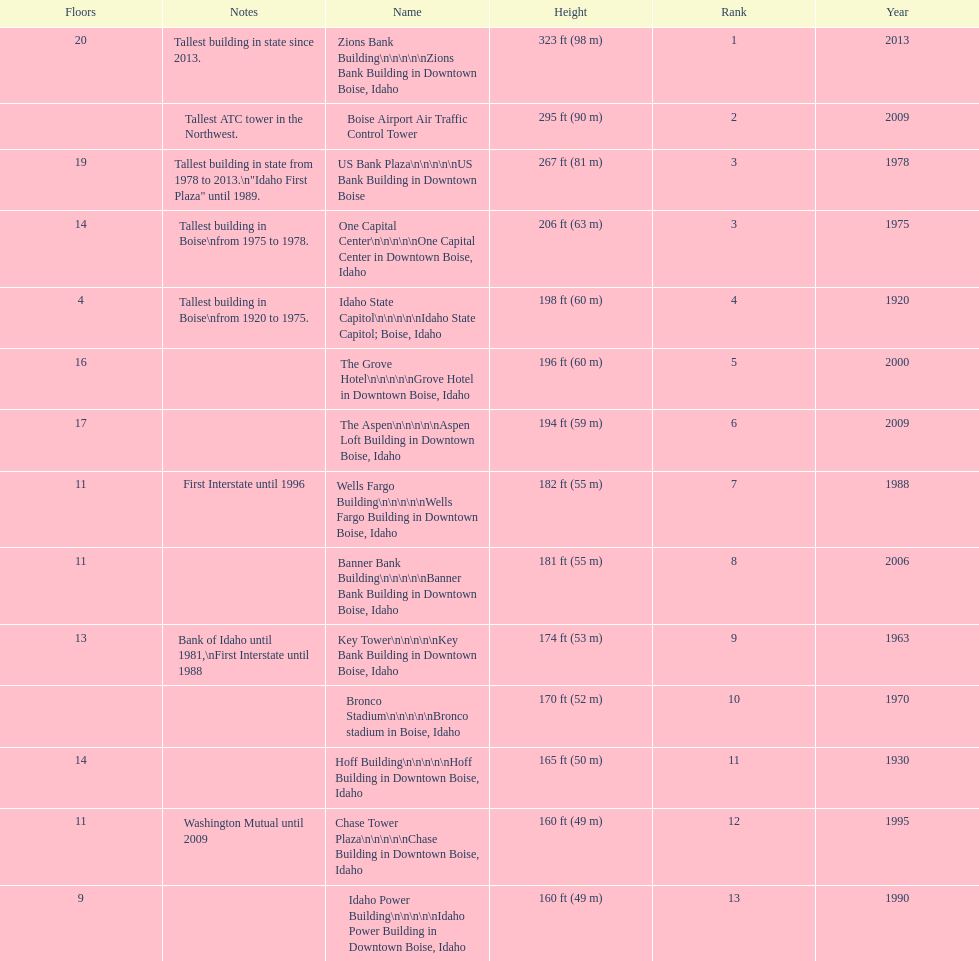What is the name of the building listed after idaho state capitol? The Grove Hotel. 